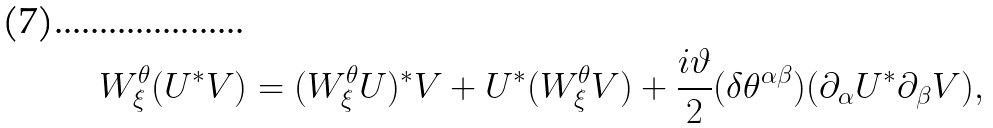<formula> <loc_0><loc_0><loc_500><loc_500>W _ { \xi } ^ { \theta } ( U ^ { * } V ) = ( W _ { \xi } ^ { \theta } U ) ^ { * } V + U ^ { * } ( W _ { \xi } ^ { \theta } V ) + \frac { i \vartheta } { 2 } ( \delta \theta ^ { \alpha \beta } ) ( \partial _ { \alpha } U ^ { * } \partial _ { \beta } V ) ,</formula> 